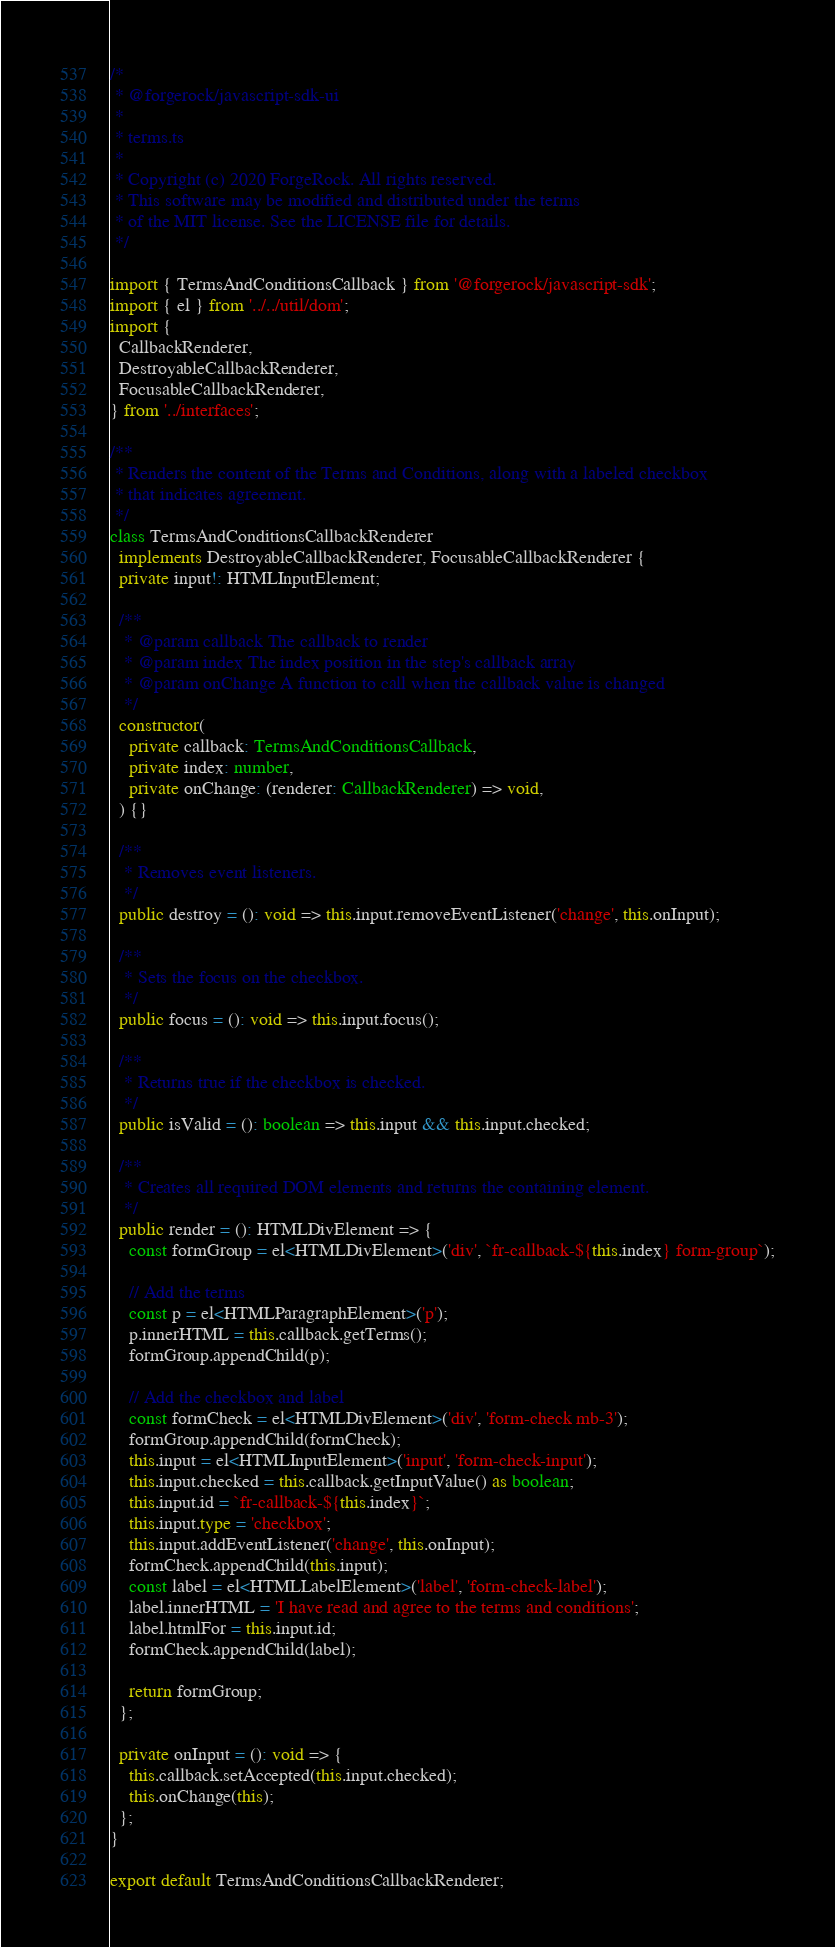Convert code to text. <code><loc_0><loc_0><loc_500><loc_500><_TypeScript_>/*
 * @forgerock/javascript-sdk-ui
 *
 * terms.ts
 *
 * Copyright (c) 2020 ForgeRock. All rights reserved.
 * This software may be modified and distributed under the terms
 * of the MIT license. See the LICENSE file for details.
 */

import { TermsAndConditionsCallback } from '@forgerock/javascript-sdk';
import { el } from '../../util/dom';
import {
  CallbackRenderer,
  DestroyableCallbackRenderer,
  FocusableCallbackRenderer,
} from '../interfaces';

/**
 * Renders the content of the Terms and Conditions, along with a labeled checkbox
 * that indicates agreement.
 */
class TermsAndConditionsCallbackRenderer
  implements DestroyableCallbackRenderer, FocusableCallbackRenderer {
  private input!: HTMLInputElement;

  /**
   * @param callback The callback to render
   * @param index The index position in the step's callback array
   * @param onChange A function to call when the callback value is changed
   */
  constructor(
    private callback: TermsAndConditionsCallback,
    private index: number,
    private onChange: (renderer: CallbackRenderer) => void,
  ) {}

  /**
   * Removes event listeners.
   */
  public destroy = (): void => this.input.removeEventListener('change', this.onInput);

  /**
   * Sets the focus on the checkbox.
   */
  public focus = (): void => this.input.focus();

  /**
   * Returns true if the checkbox is checked.
   */
  public isValid = (): boolean => this.input && this.input.checked;

  /**
   * Creates all required DOM elements and returns the containing element.
   */
  public render = (): HTMLDivElement => {
    const formGroup = el<HTMLDivElement>('div', `fr-callback-${this.index} form-group`);

    // Add the terms
    const p = el<HTMLParagraphElement>('p');
    p.innerHTML = this.callback.getTerms();
    formGroup.appendChild(p);

    // Add the checkbox and label
    const formCheck = el<HTMLDivElement>('div', 'form-check mb-3');
    formGroup.appendChild(formCheck);
    this.input = el<HTMLInputElement>('input', 'form-check-input');
    this.input.checked = this.callback.getInputValue() as boolean;
    this.input.id = `fr-callback-${this.index}`;
    this.input.type = 'checkbox';
    this.input.addEventListener('change', this.onInput);
    formCheck.appendChild(this.input);
    const label = el<HTMLLabelElement>('label', 'form-check-label');
    label.innerHTML = 'I have read and agree to the terms and conditions';
    label.htmlFor = this.input.id;
    formCheck.appendChild(label);

    return formGroup;
  };

  private onInput = (): void => {
    this.callback.setAccepted(this.input.checked);
    this.onChange(this);
  };
}

export default TermsAndConditionsCallbackRenderer;
</code> 